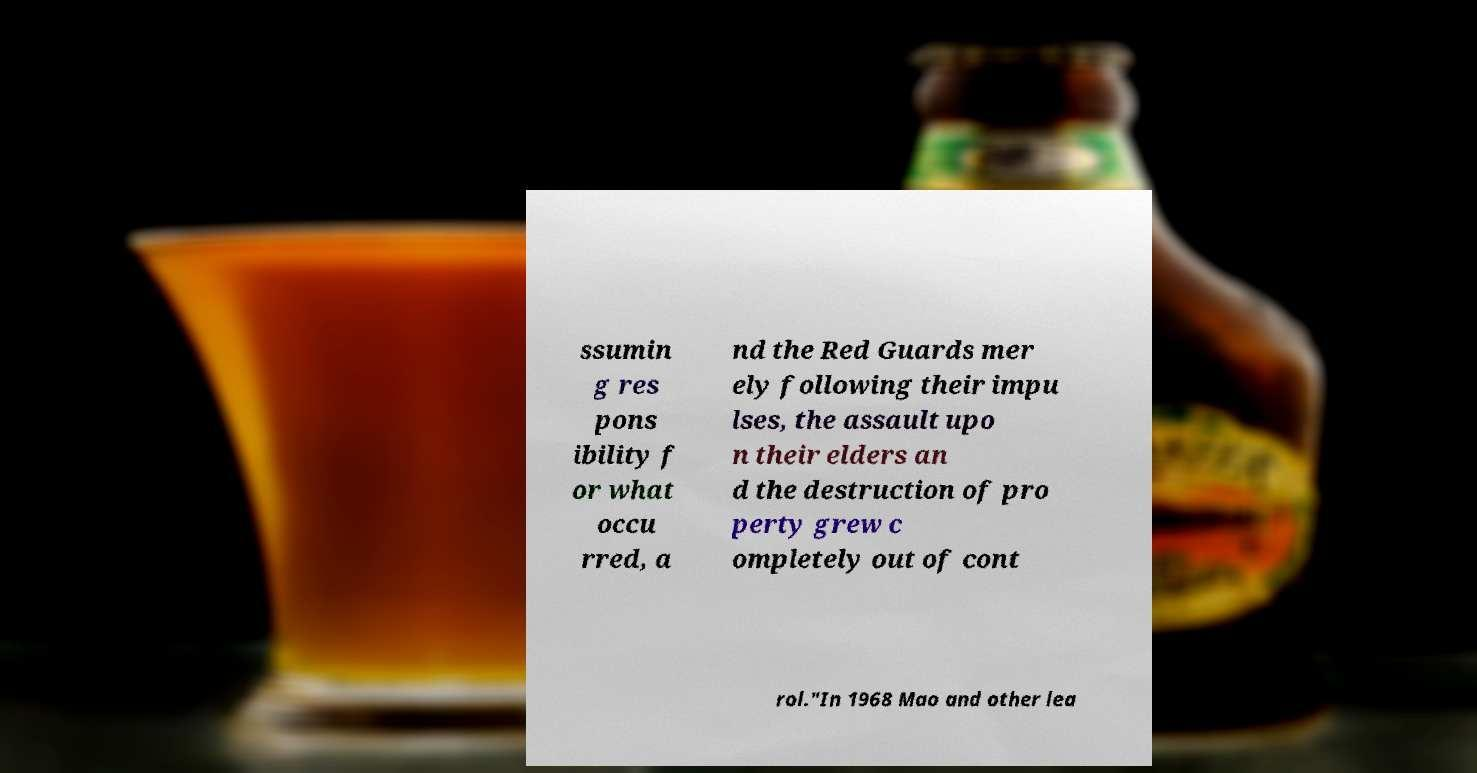I need the written content from this picture converted into text. Can you do that? ssumin g res pons ibility f or what occu rred, a nd the Red Guards mer ely following their impu lses, the assault upo n their elders an d the destruction of pro perty grew c ompletely out of cont rol."In 1968 Mao and other lea 